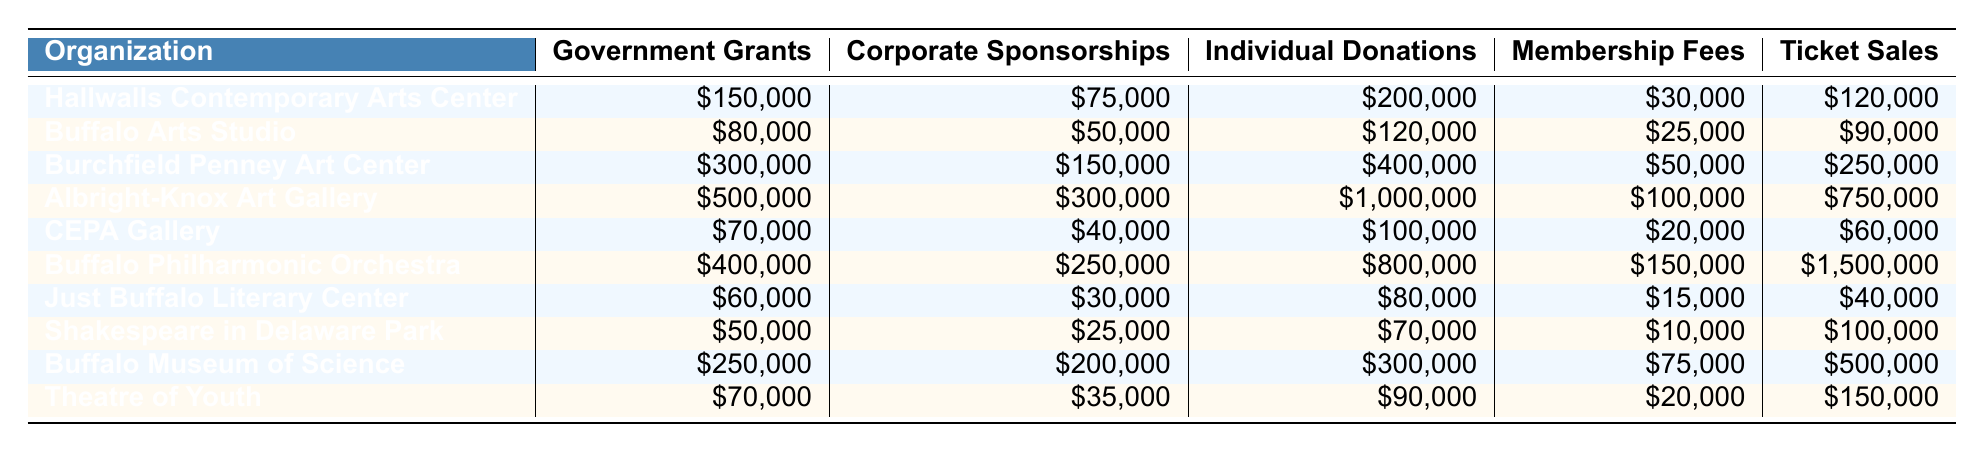What is the total funding from Government Grants for Hallwalls Contemporary Arts Center? The funding amount for Government Grants for Hallwalls Contemporary Arts Center is listed as $150,000.
Answer: $150,000 Which organization has the highest total in Individual Donations? By examining the Individual Donations column, Albright-Knox Art Gallery shows the highest amount at $1,000,000, making it the organization with the highest total in this category.
Answer: Albright-Knox Art Gallery What is the combined total of Government Grants for Burchfield Penney Art Center and Buffalo Museum of Science? Burchfield Penney Art Center has $300,000 in Government Grants, and Buffalo Museum of Science has $250,000. Adding these amounts together gives $300,000 + $250,000 = $550,000.
Answer: $550,000 Is the Corporate Sponsorship amount for Just Buffalo Literary Center greater than $30,000? The Corporate Sponsorship amount listed for Just Buffalo Literary Center is $30,000, which does not exceed that amount. Therefore, the answer is no.
Answer: No What is the total funding across all categories for the Buffalo Philharmonic Orchestra? To find the total funding for Buffalo Philharmonic Orchestra, we add all its funding sources: $400,000 (Government Grants) + $250,000 (Corporate Sponsorships) + $800,000 (Individual Donations) + $150,000 (Membership Fees) + $1,500,000 (Ticket Sales) = $3,100,000.
Answer: $3,100,000 Which organization has the least amount in Membership Fees? Looking at the Membership Fees column, we see that Shakespeare in Delaware Park has the least amount at $10,000.
Answer: Shakespeare in Delaware Park What is the difference between the highest and lowest amounts in Ticket Sales? The highest amount in Ticket Sales is from Buffalo Philharmonic Orchestra at $1,500,000, while the lowest is from Just Buffalo Literary Center at $40,000. The difference is $1,500,000 - $40,000 = $1,460,000.
Answer: $1,460,000 Does Buffalo Arts Studio have more funding from Individual Donations than Hallwalls Contemporary Arts Center? Buffalo Arts Studio has $120,000 in Individual Donations, while Hallwalls Contemporary Arts Center has $200,000. Since $120,000 is less than $200,000, the answer is no.
Answer: No What is the average amount of Corporate Sponsorships for the organizations listed? To find the average, first sum the Corporate Sponsorships: $75,000 + $50,000 + $150,000 + $300,000 + $40,000 + $250,000 + $30,000 + $25,000 + $200,000 + $35,000 = $1,155,000. There are 10 organizations, so the average is $1,155,000/10 = $115,500.
Answer: $115,500 Which organization has the largest amount in Ticket Sales? The Ticket Sales for Buffalo Philharmonic Orchestra is $1,500,000, which is the highest amount in that category as compared to all other organizations listed.
Answer: Buffalo Philharmonic Orchestra 